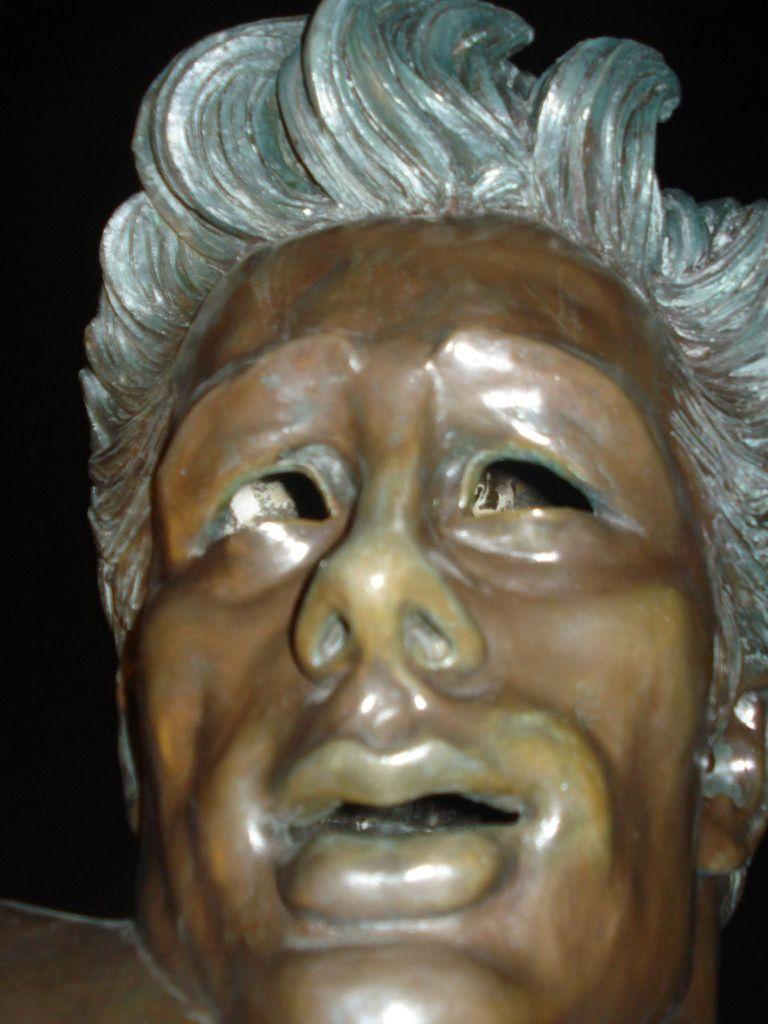How would you summarize this image in a sentence or two? In this image there is a sculpture. In the image there is a face on which there is white chair. 